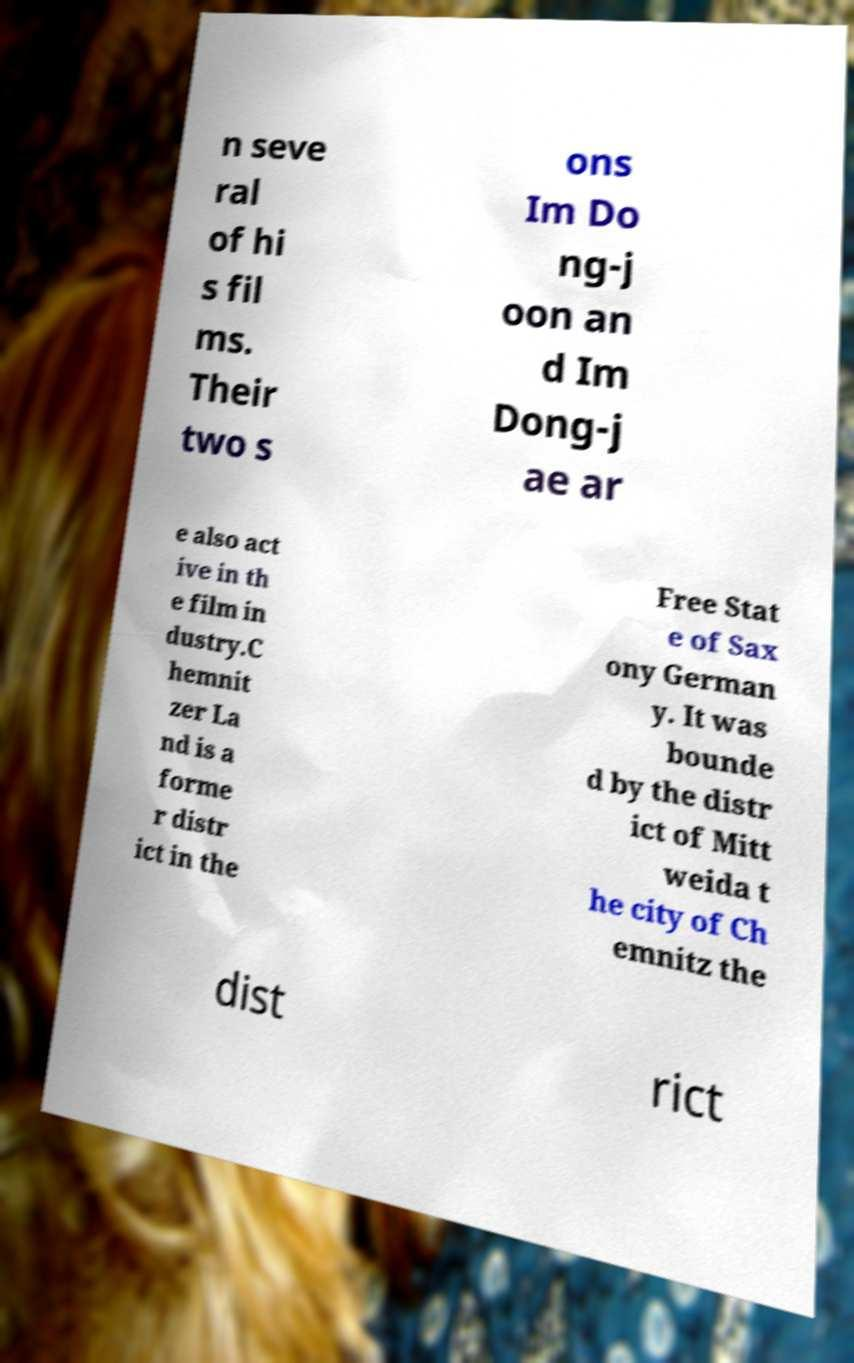Can you read and provide the text displayed in the image?This photo seems to have some interesting text. Can you extract and type it out for me? n seve ral of hi s fil ms. Their two s ons Im Do ng-j oon an d Im Dong-j ae ar e also act ive in th e film in dustry.C hemnit zer La nd is a forme r distr ict in the Free Stat e of Sax ony German y. It was bounde d by the distr ict of Mitt weida t he city of Ch emnitz the dist rict 